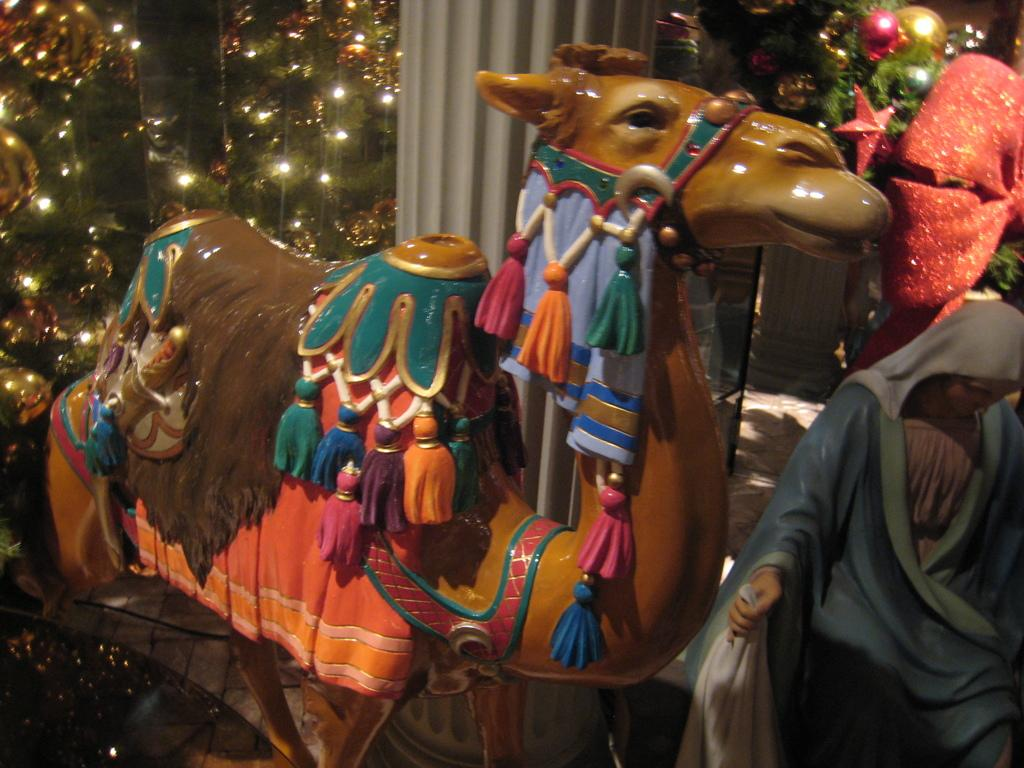What type of sculptures can be seen in the image? There is a sculpture of an animal and a sculpture of a person in the image. What additional feature is visible in the image? There are tiny lights visible in the image. What architectural element can be seen in the image? There is a pillar in the image. What type of detail is present in the image? There is decorative detail in the image. What type of weather can be seen in the image? There is no weather visible in the image; it is a still image of sculptures and other elements. What type of fang is present on the animal sculpture in the image? There is no fang present on the animal sculpture in the image; it is a sculpture, not a real animal. 